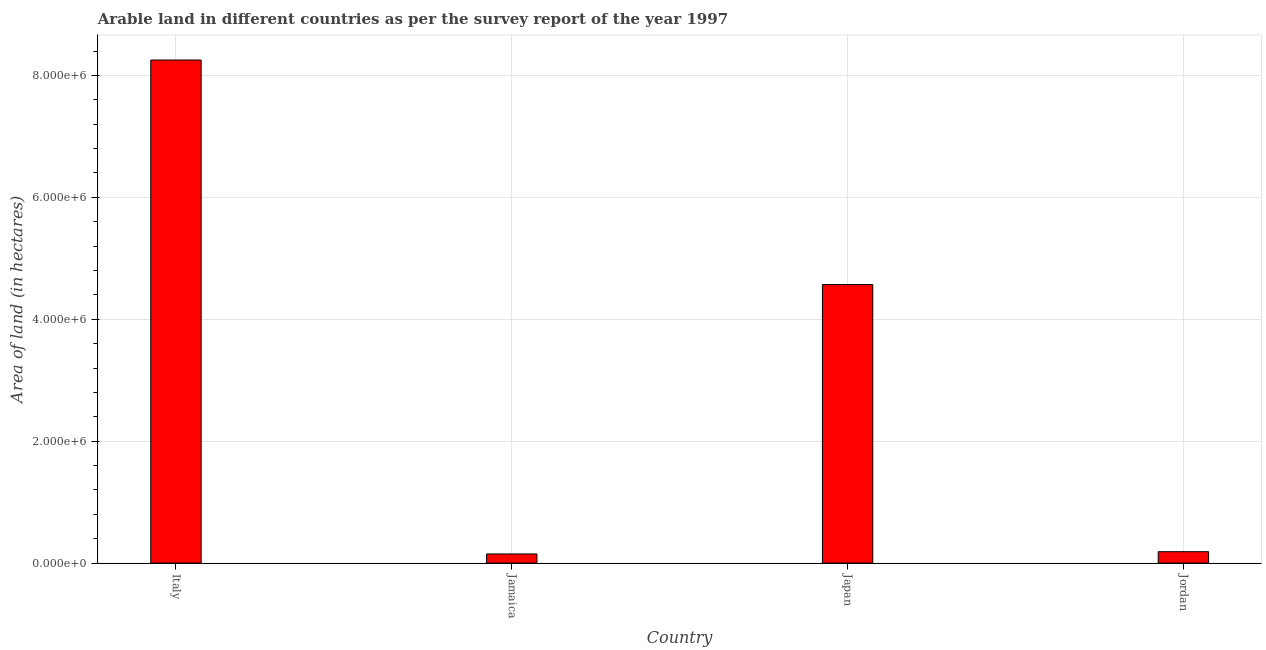Does the graph contain any zero values?
Offer a terse response. No. What is the title of the graph?
Make the answer very short. Arable land in different countries as per the survey report of the year 1997. What is the label or title of the Y-axis?
Your answer should be compact. Area of land (in hectares). What is the area of land in Jordan?
Give a very brief answer. 1.87e+05. Across all countries, what is the maximum area of land?
Offer a terse response. 8.25e+06. In which country was the area of land minimum?
Ensure brevity in your answer.  Jamaica. What is the sum of the area of land?
Offer a very short reply. 1.32e+07. What is the difference between the area of land in Italy and Jamaica?
Ensure brevity in your answer.  8.10e+06. What is the average area of land per country?
Make the answer very short. 3.29e+06. What is the median area of land?
Your response must be concise. 2.38e+06. In how many countries, is the area of land greater than 2000000 hectares?
Give a very brief answer. 2. What is the ratio of the area of land in Jamaica to that in Jordan?
Offer a very short reply. 0.8. Is the area of land in Jamaica less than that in Japan?
Provide a succinct answer. Yes. Is the difference between the area of land in Jamaica and Japan greater than the difference between any two countries?
Make the answer very short. No. What is the difference between the highest and the second highest area of land?
Your answer should be compact. 3.68e+06. Is the sum of the area of land in Italy and Jamaica greater than the maximum area of land across all countries?
Your answer should be very brief. Yes. What is the difference between the highest and the lowest area of land?
Keep it short and to the point. 8.10e+06. Are all the bars in the graph horizontal?
Offer a very short reply. No. What is the Area of land (in hectares) of Italy?
Provide a succinct answer. 8.25e+06. What is the Area of land (in hectares) of Jamaica?
Your answer should be compact. 1.50e+05. What is the Area of land (in hectares) of Japan?
Offer a very short reply. 4.57e+06. What is the Area of land (in hectares) in Jordan?
Give a very brief answer. 1.87e+05. What is the difference between the Area of land (in hectares) in Italy and Jamaica?
Offer a very short reply. 8.10e+06. What is the difference between the Area of land (in hectares) in Italy and Japan?
Your answer should be compact. 3.68e+06. What is the difference between the Area of land (in hectares) in Italy and Jordan?
Keep it short and to the point. 8.07e+06. What is the difference between the Area of land (in hectares) in Jamaica and Japan?
Ensure brevity in your answer.  -4.42e+06. What is the difference between the Area of land (in hectares) in Jamaica and Jordan?
Your response must be concise. -3.70e+04. What is the difference between the Area of land (in hectares) in Japan and Jordan?
Your answer should be compact. 4.38e+06. What is the ratio of the Area of land (in hectares) in Italy to that in Jamaica?
Make the answer very short. 55.02. What is the ratio of the Area of land (in hectares) in Italy to that in Japan?
Your response must be concise. 1.81. What is the ratio of the Area of land (in hectares) in Italy to that in Jordan?
Provide a succinct answer. 44.13. What is the ratio of the Area of land (in hectares) in Jamaica to that in Japan?
Offer a terse response. 0.03. What is the ratio of the Area of land (in hectares) in Jamaica to that in Jordan?
Ensure brevity in your answer.  0.8. What is the ratio of the Area of land (in hectares) in Japan to that in Jordan?
Keep it short and to the point. 24.43. 